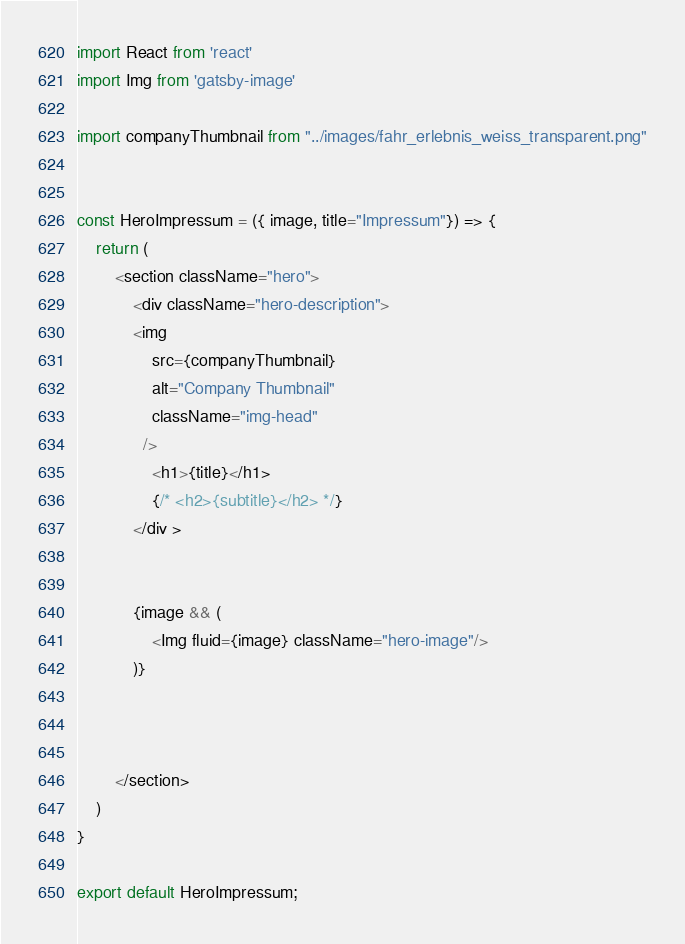<code> <loc_0><loc_0><loc_500><loc_500><_JavaScript_>import React from 'react'
import Img from 'gatsby-image'

import companyThumbnail from "../images/fahr_erlebnis_weiss_transparent.png"


const HeroImpressum = ({ image, title="Impressum"}) => {
    return (
        <section className="hero">
            <div className="hero-description">
            <img
                src={companyThumbnail}
                alt="Company Thumbnail"
                className="img-head"
              />    
                <h1>{title}</h1>
                {/* <h2>{subtitle}</h2> */}
            </div >
           

            {image && (
                <Img fluid={image} className="hero-image"/>
            )}


         
        </section>
    )
}

export default HeroImpressum;
</code> 